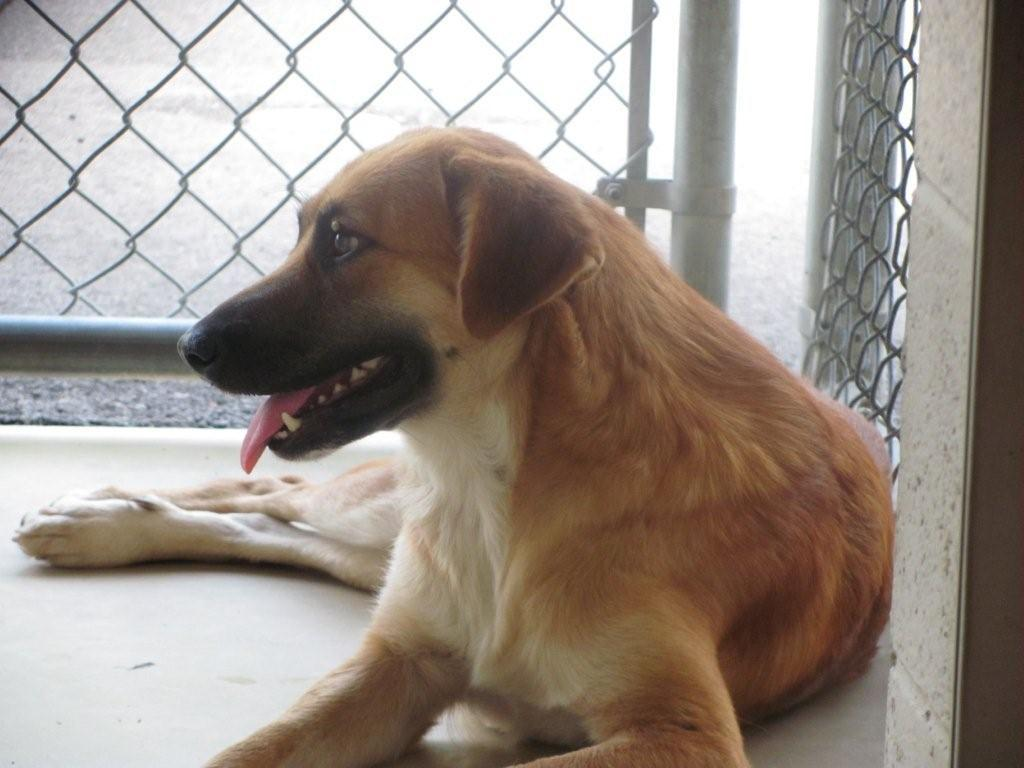What type of animal is in the image? There is a dog in the image. Can you describe the dog's appearance? The dog is white and brown in color. What is the dog standing near in the image? There is a metal fence in the image. What type of history is the dog studying in the image? There is no indication in the image that the dog is studying history or any other subject. 